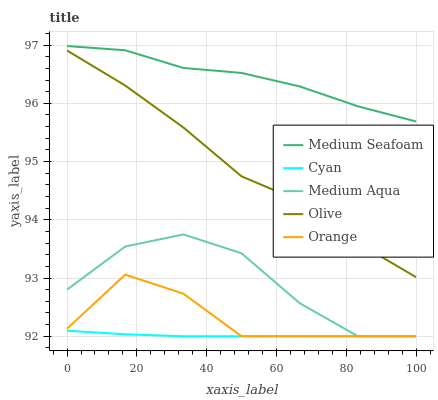Does Cyan have the minimum area under the curve?
Answer yes or no. Yes. Does Medium Seafoam have the maximum area under the curve?
Answer yes or no. Yes. Does Orange have the minimum area under the curve?
Answer yes or no. No. Does Orange have the maximum area under the curve?
Answer yes or no. No. Is Cyan the smoothest?
Answer yes or no. Yes. Is Medium Aqua the roughest?
Answer yes or no. Yes. Is Orange the smoothest?
Answer yes or no. No. Is Orange the roughest?
Answer yes or no. No. Does Cyan have the lowest value?
Answer yes or no. Yes. Does Medium Seafoam have the lowest value?
Answer yes or no. No. Does Medium Seafoam have the highest value?
Answer yes or no. Yes. Does Orange have the highest value?
Answer yes or no. No. Is Medium Aqua less than Medium Seafoam?
Answer yes or no. Yes. Is Olive greater than Orange?
Answer yes or no. Yes. Does Cyan intersect Medium Aqua?
Answer yes or no. Yes. Is Cyan less than Medium Aqua?
Answer yes or no. No. Is Cyan greater than Medium Aqua?
Answer yes or no. No. Does Medium Aqua intersect Medium Seafoam?
Answer yes or no. No. 